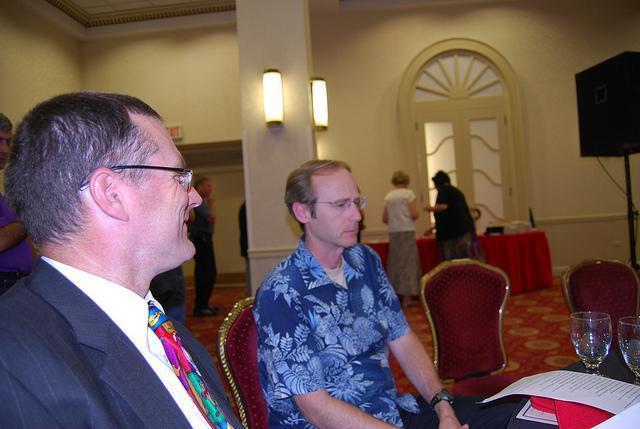How many women are visible in the background?
Give a very brief answer. 2. How many chairs can you see?
Give a very brief answer. 3. How many people can you see?
Give a very brief answer. 6. How many cows are standing up?
Give a very brief answer. 0. 